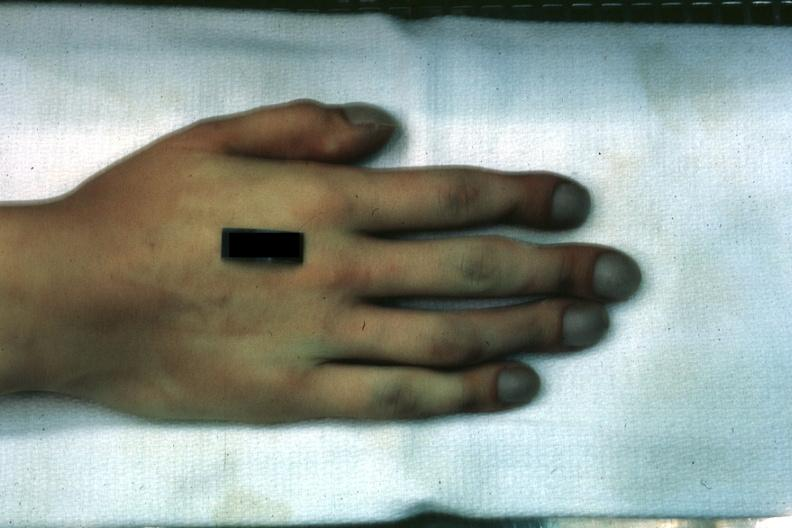does pituitary show case of transposition of great vessels with vsd age 22 yrs?
Answer the question using a single word or phrase. No 